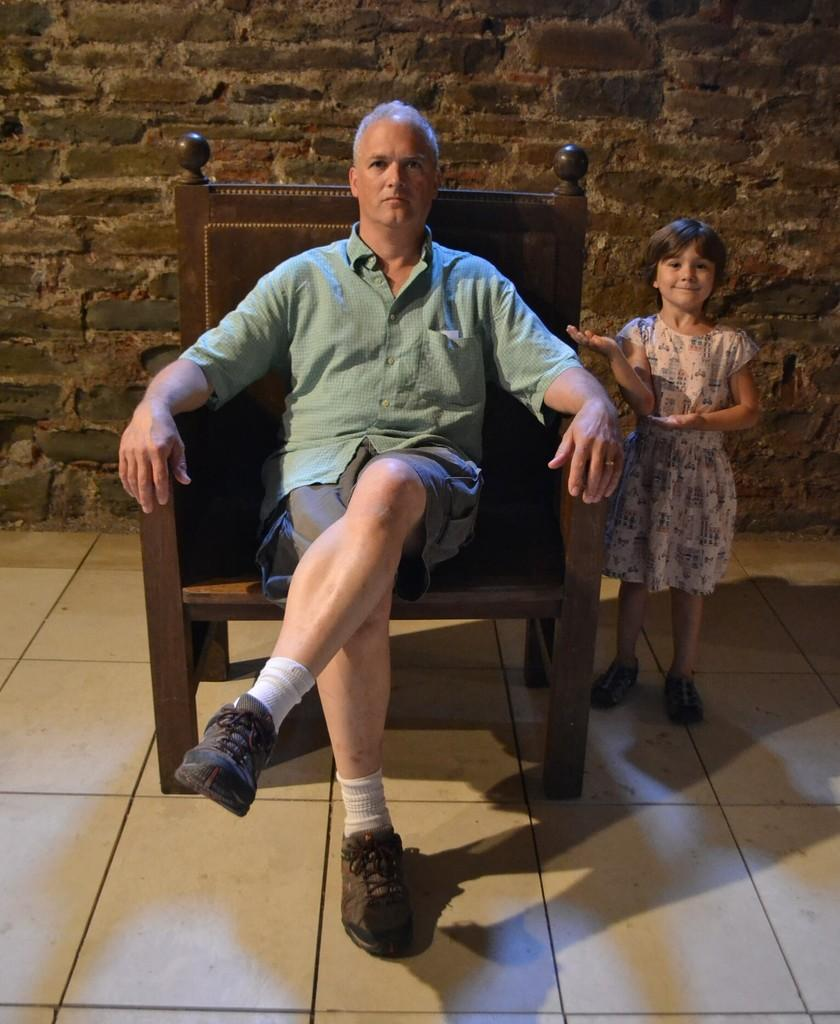What is the man in the image doing? The man is sitting on a chair in the image. What is the girl in the image doing? The girl is standing in the image. What can be seen in the background of the image? There is a wall in the background of the image. What type of ticket does the pet have in the image? There is no pet present in the image, so there is no ticket to discuss. 